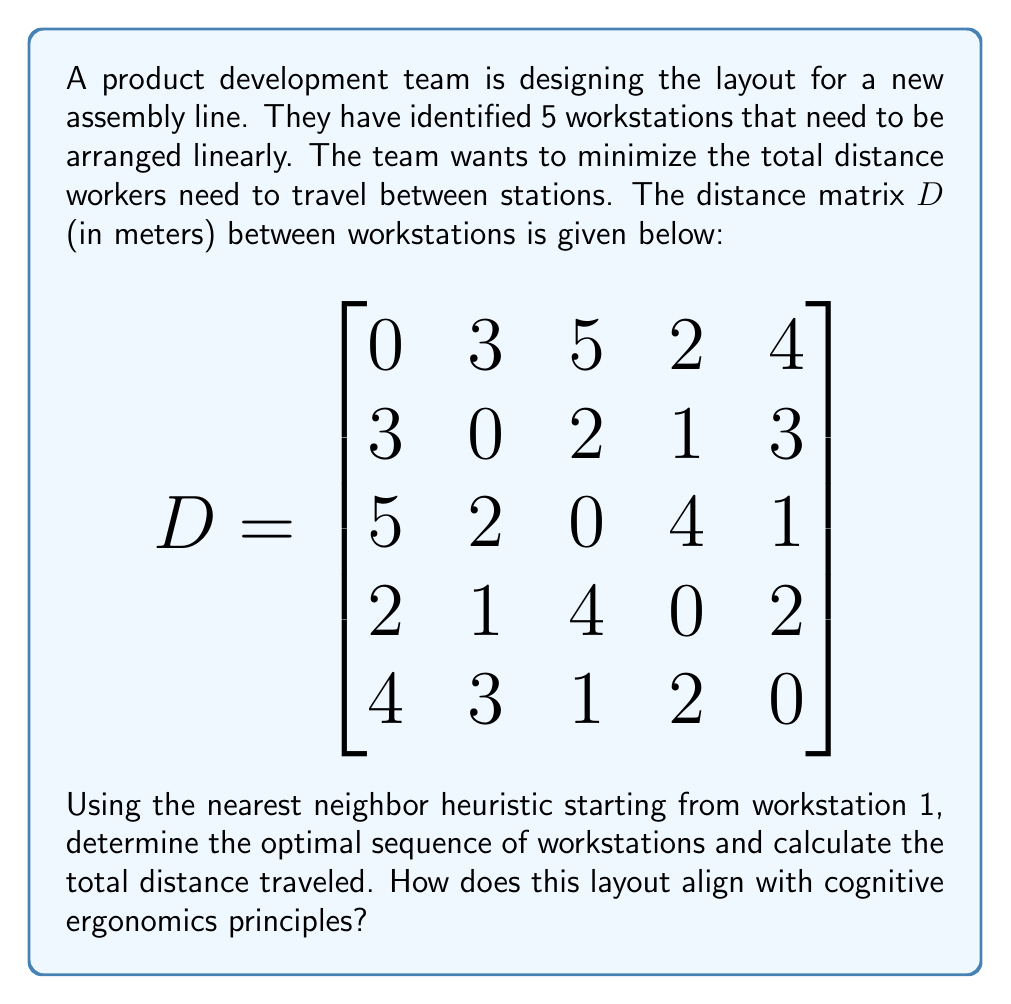Can you answer this question? To solve this problem, we'll use the nearest neighbor heuristic, which is a simple numerical optimization method. This approach aligns with the industrial engineer's interest in incorporating cognitive psychology principles, as it mimics human decision-making processes.

Step 1: Start at workstation 1.

Step 2: Find the nearest unvisited workstation:
- From workstation 1, the nearest is workstation 4 (2 meters).

Step 3: Move to workstation 4 and repeat the process:
- From workstation 4, the nearest unvisited is workstation 2 (1 meter).

Step 4: Move to workstation 2 and repeat:
- From workstation 2, the nearest unvisited is workstation 5 (3 meters).

Step 5: Move to workstation 5:
- The only remaining workstation is 3 (1 meter).

Step 6: Calculate the total distance:
$2 + 1 + 3 + 1 = 7$ meters

The optimal sequence is: 1 → 4 → 2 → 5 → 3

Alignment with cognitive ergonomics:
1. Proximity principle: The layout minimizes distances, reducing cognitive load on workers.
2. Sequencing: The arrangement follows a logical sequence, which can improve task memory and reduce errors.
3. Consistency: Regular distances between workstations can create a rhythm, potentially improving worker performance.
4. Cognitive flow: The layout supports a natural progression of tasks, potentially reducing mental strain.
Answer: The optimal sequence of workstations is 1 → 4 → 2 → 5 → 3, with a total distance of 7 meters. 